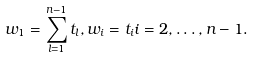<formula> <loc_0><loc_0><loc_500><loc_500>w _ { 1 } = \sum _ { l = 1 } ^ { n - 1 } t _ { l } , w _ { i } = t _ { i } i = 2 , \dots , n - 1 .</formula> 